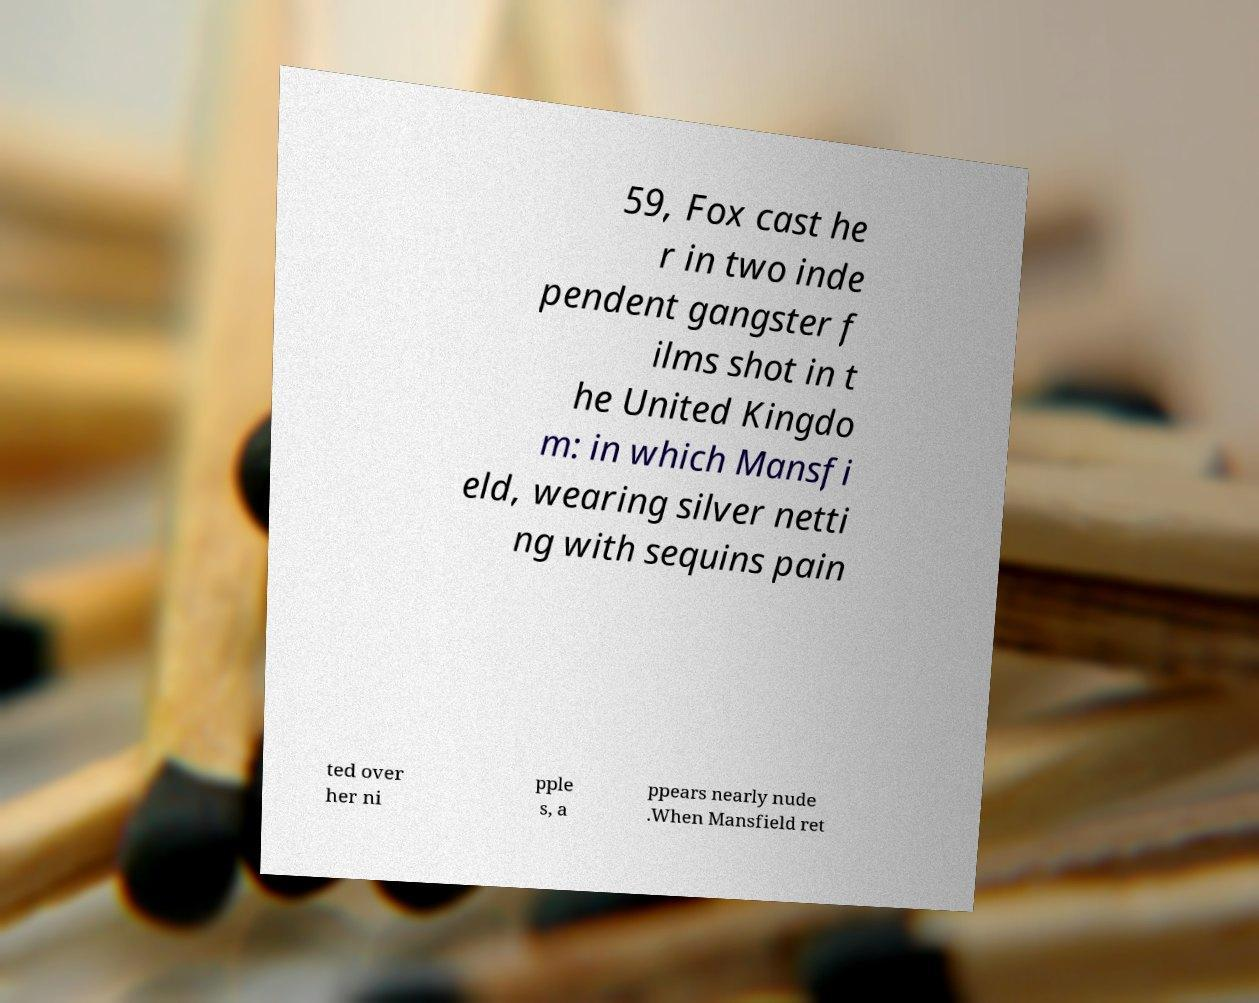Can you accurately transcribe the text from the provided image for me? 59, Fox cast he r in two inde pendent gangster f ilms shot in t he United Kingdo m: in which Mansfi eld, wearing silver netti ng with sequins pain ted over her ni pple s, a ppears nearly nude .When Mansfield ret 